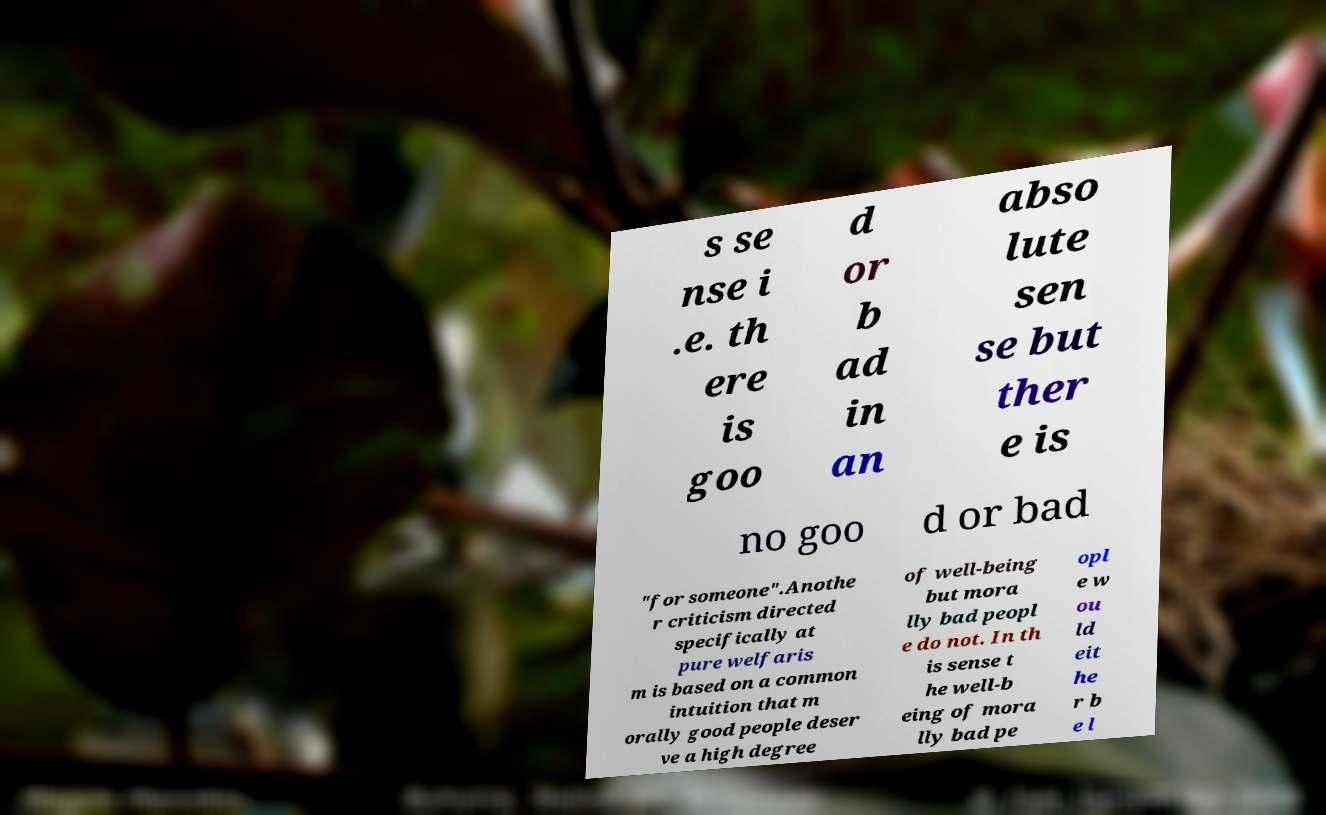Can you read and provide the text displayed in the image?This photo seems to have some interesting text. Can you extract and type it out for me? s se nse i .e. th ere is goo d or b ad in an abso lute sen se but ther e is no goo d or bad "for someone".Anothe r criticism directed specifically at pure welfaris m is based on a common intuition that m orally good people deser ve a high degree of well-being but mora lly bad peopl e do not. In th is sense t he well-b eing of mora lly bad pe opl e w ou ld eit he r b e l 